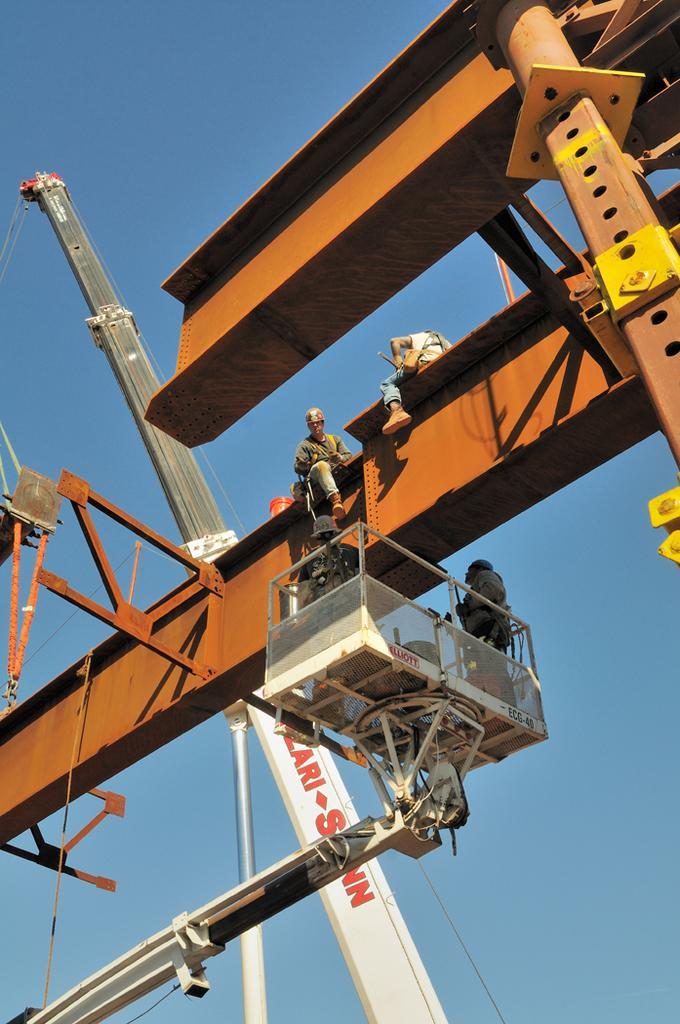Who or what can be seen in the image? There are people in the image. What type of machinery is present in the image? There is a crane and boom lifts in the image. What material is the metal object made of? The metal object in the image is made of metal. What can be seen in the background of the image? The sky is visible in the background of the image. What type of lettuce is being used as a prop in the image? There is no lettuce present in the image. What class are the people attending in the image? There is no indication of a class or educational setting in the image. 